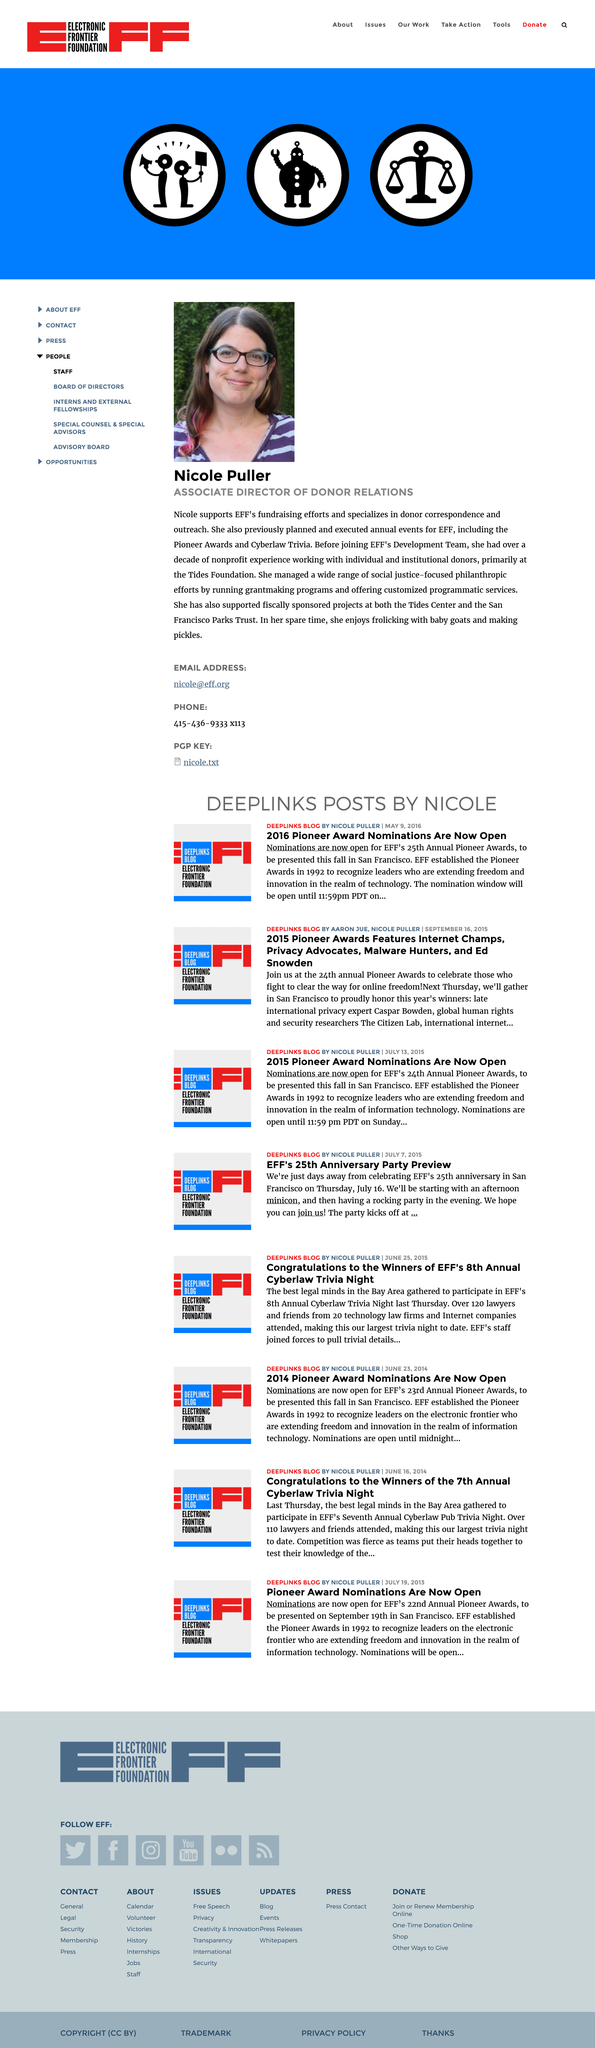Point out several critical features in this image. Nicole Puller is a member of the EFF Development team, as stated in the text. Nicole Puller engages in frolicking with baby goats and making pickles in her leisure time. Nicole Puller is the Associate Director of Donor Relations. 